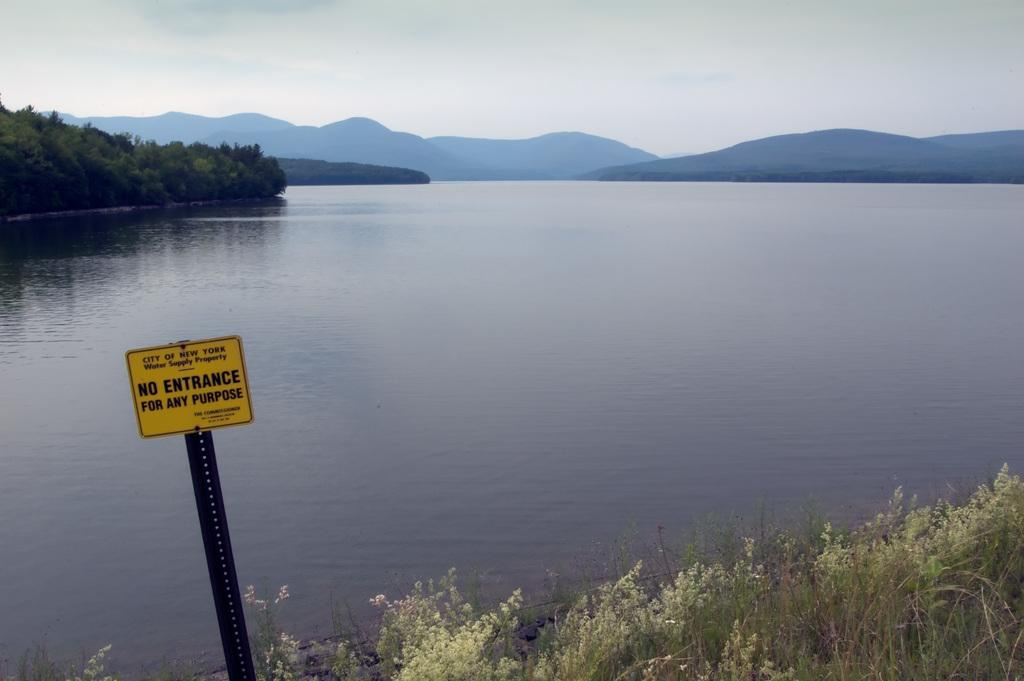What body of water is present in the image? There is a lake in the image. Are there any features within the lake? Yes, there are small islands in the lake. What can be seen on the left side of the image? There is a caution board on the left side of the image. What type of vegetation is on the right side of the image? There is grass on the ground on the right side of the image. What is visible at the top of the image? The sky is visible at the top of the image. What type of religion is practiced on the minute table in the image? There is no table present in the image, let alone a minute table or any religious practice depicted. 